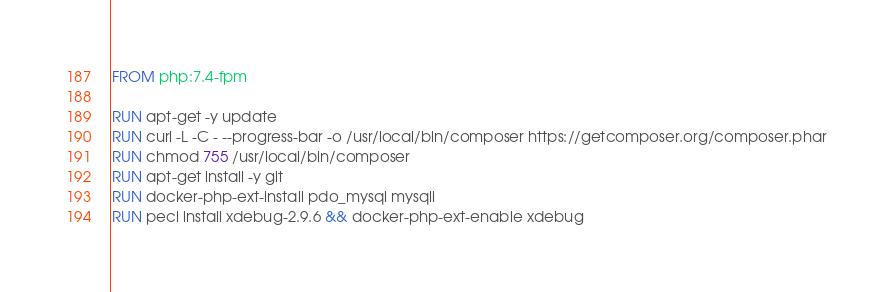<code> <loc_0><loc_0><loc_500><loc_500><_Dockerfile_>FROM php:7.4-fpm

RUN apt-get -y update
RUN curl -L -C - --progress-bar -o /usr/local/bin/composer https://getcomposer.org/composer.phar
RUN chmod 755 /usr/local/bin/composer
RUN apt-get install -y git
RUN docker-php-ext-install pdo_mysql mysqli
RUN pecl install xdebug-2.9.6 && docker-php-ext-enable xdebug
</code> 